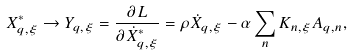Convert formula to latex. <formula><loc_0><loc_0><loc_500><loc_500>X _ { { q } , \xi } ^ { * } \rightarrow Y _ { { q } , \xi } = \frac { \partial { L } } { \partial \dot { X } ^ { * } _ { { q } , \xi } } = \rho \dot { X } _ { { q } , \xi } - \alpha \sum _ { n } K _ { n , \xi } A _ { { q } , n } ,</formula> 